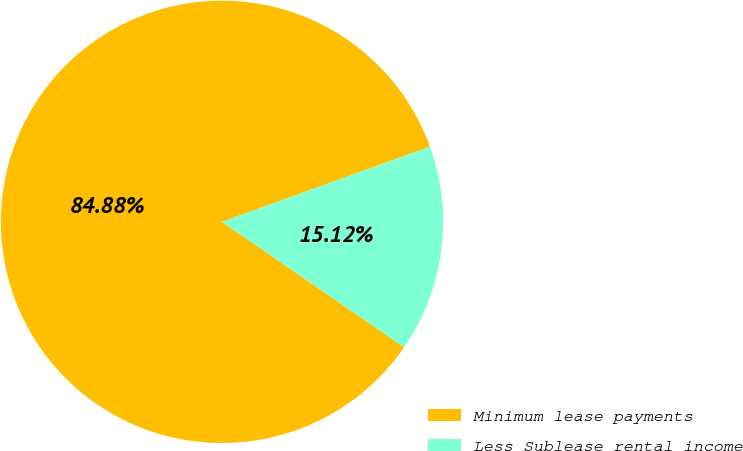Convert chart to OTSL. <chart><loc_0><loc_0><loc_500><loc_500><pie_chart><fcel>Minimum lease payments<fcel>Less Sublease rental income<nl><fcel>84.88%<fcel>15.12%<nl></chart> 